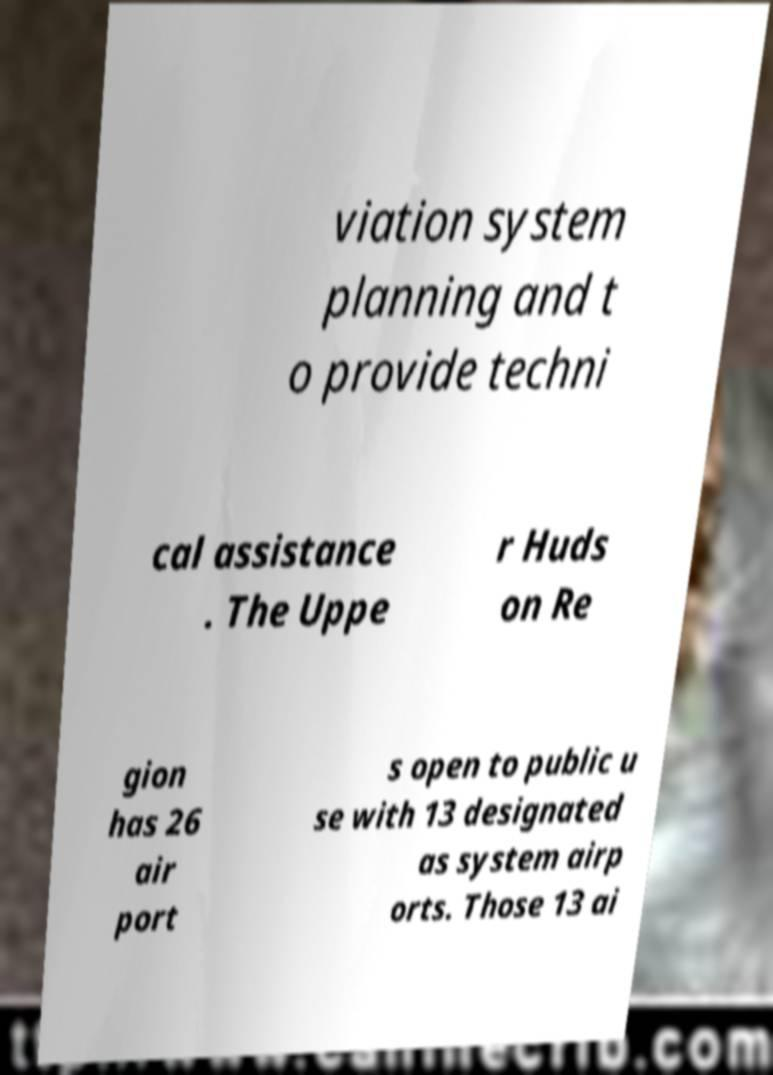Please identify and transcribe the text found in this image. viation system planning and t o provide techni cal assistance . The Uppe r Huds on Re gion has 26 air port s open to public u se with 13 designated as system airp orts. Those 13 ai 